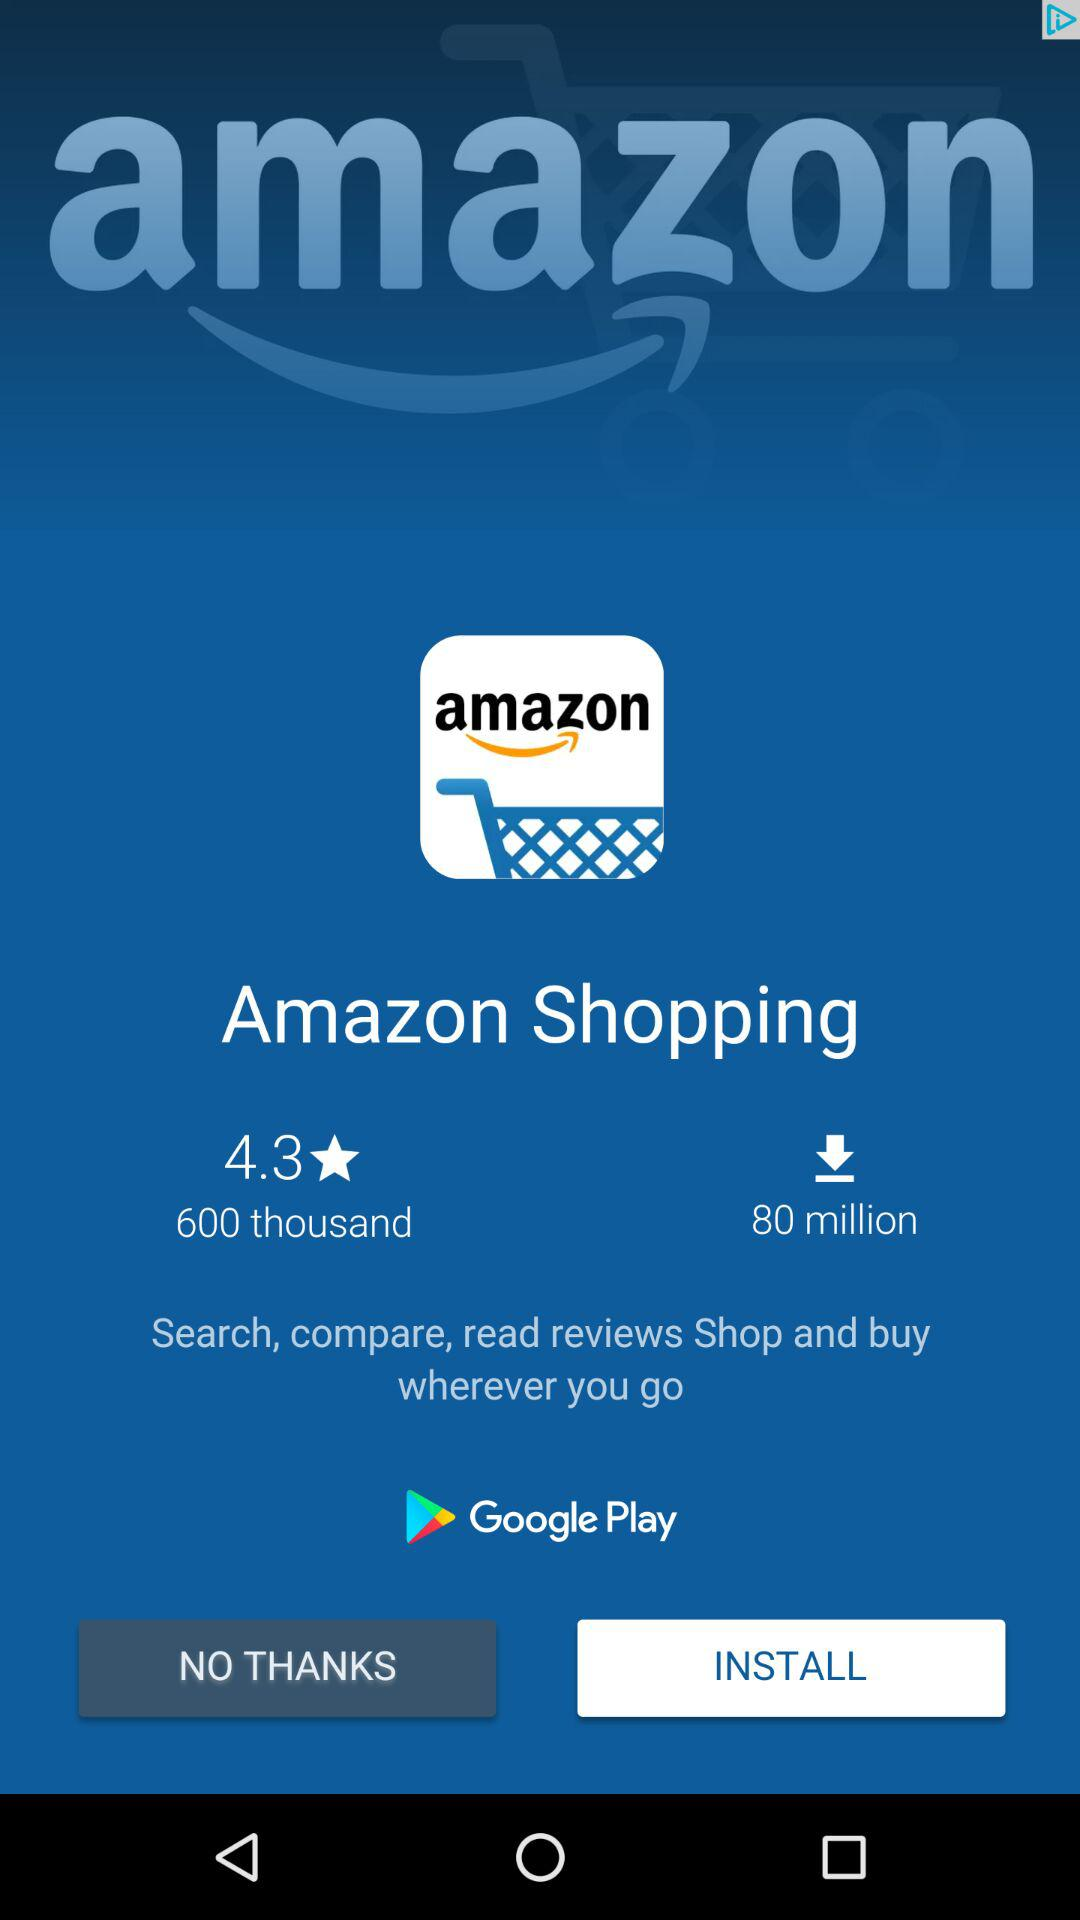How many more downloads does Amazon Shopping have than reviews?
Answer the question using a single word or phrase. 79400000 